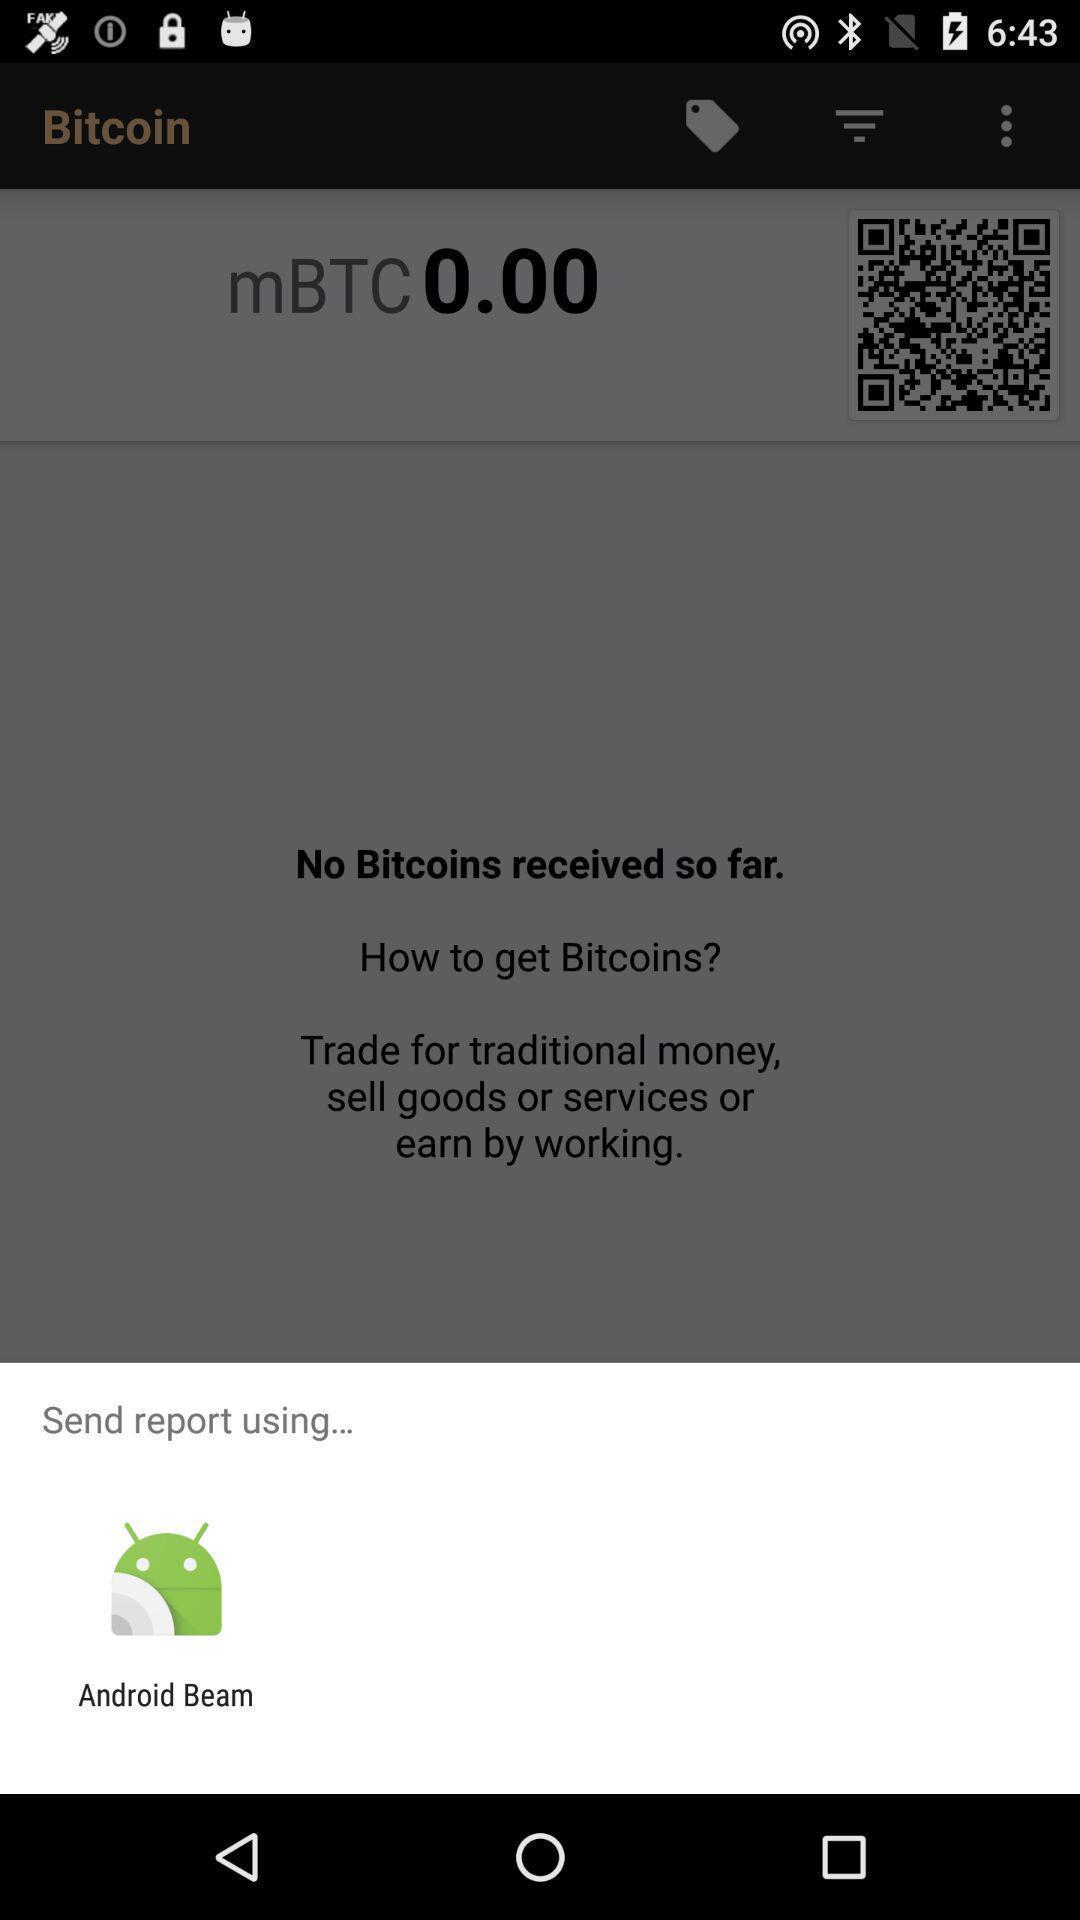Provide a detailed account of this screenshot. Pop-up displaying application to send. 